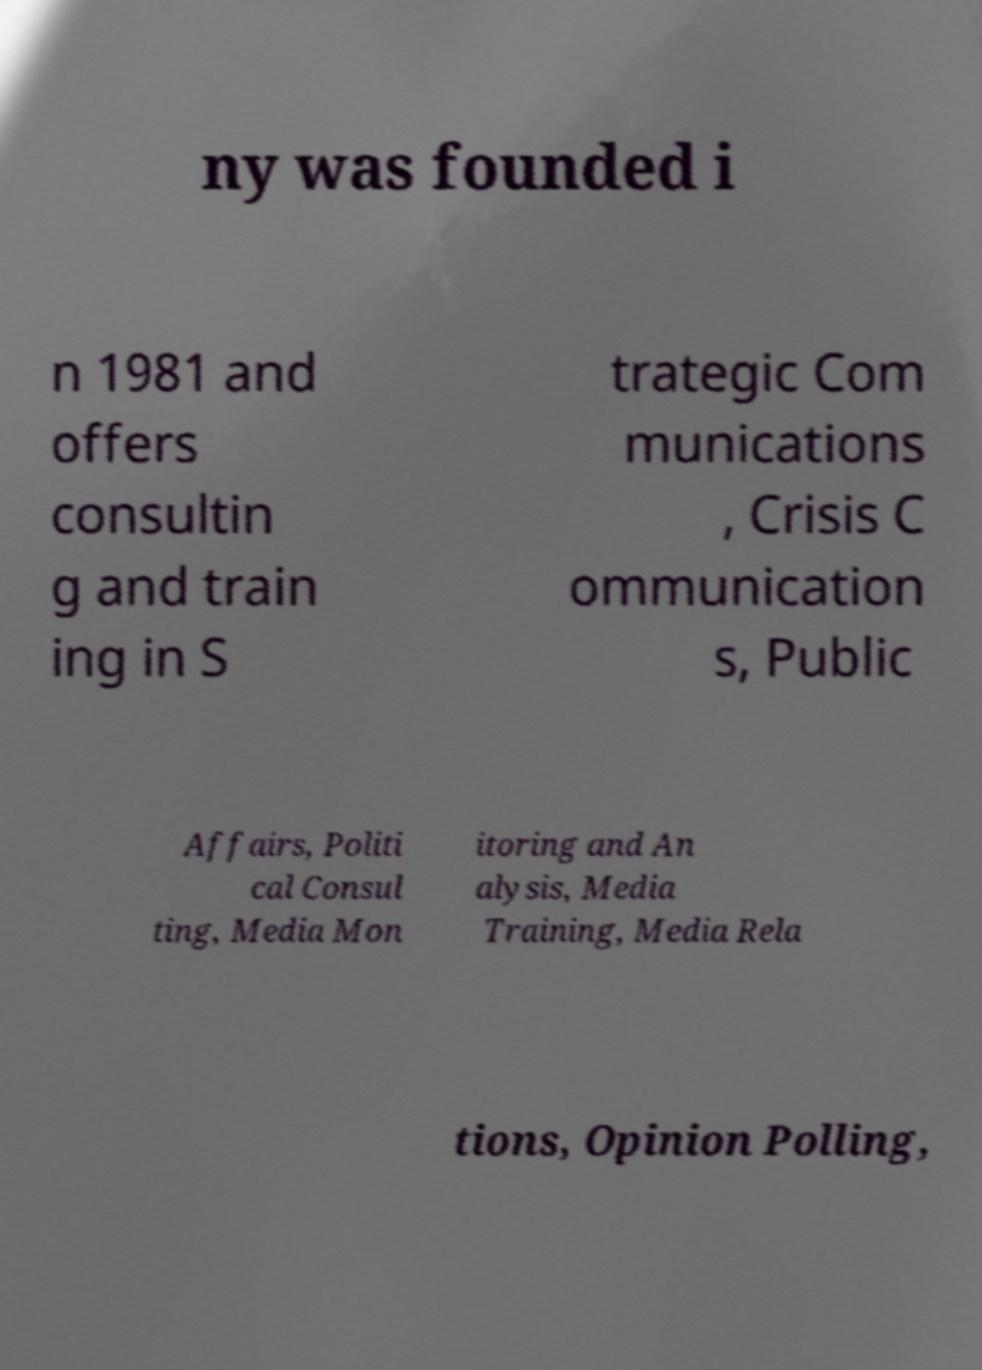Could you extract and type out the text from this image? ny was founded i n 1981 and offers consultin g and train ing in S trategic Com munications , Crisis C ommunication s, Public Affairs, Politi cal Consul ting, Media Mon itoring and An alysis, Media Training, Media Rela tions, Opinion Polling, 